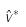<formula> <loc_0><loc_0><loc_500><loc_500>\hat { v } ^ { * }</formula> 